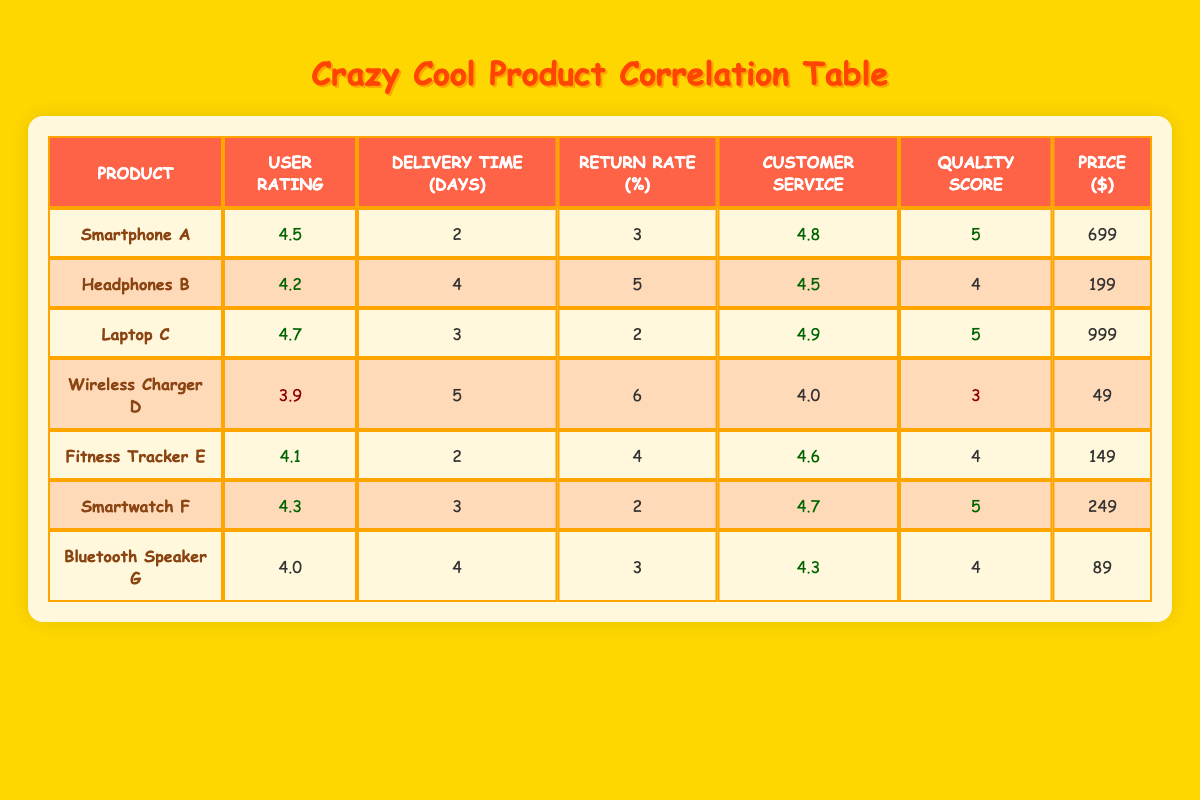What is the user rating of Laptop C? The user rating of Laptop C is listed in the corresponding row under "User Rating." Referring to the table, Laptop C has a user rating of 4.7.
Answer: 4.7 How many days did it take for the delivery of Wireless Charger D? The delivery time for Wireless Charger D is mentioned in the table. According to the row for Wireless Charger D, it took 5 days for the delivery.
Answer: 5 Which product has the highest customer service satisfaction? By checking the "Customer Service" column, we can identify the highest value. The highest customer service satisfaction is 4.9, which belongs to Laptop C.
Answer: Laptop C What is the average price of the products listed? To find the average price, we first sum the prices: 699 + 199 + 999 + 49 + 149 + 249 + 89 = 2433. There are 7 products, so the average price is 2433 divided by 7, which equals approximately 347.57.
Answer: 347.57 Is the return rate of Fitness Tracker E higher than the user rating of Smartphone A? The return rate of Fitness Tracker E is 4%, and the user rating of Smartphone A is 4.5. Since 4 is less than 4.5, the statement is false.
Answer: No Which product has the lowest quality score? The quality scores are compared, and the lowest score is found in Wireless Charger D, which has a score of 3.
Answer: Wireless Charger D Would you say that a lower price corresponds to a higher user rating based on the table data? To analyze, we look at the prices and user ratings together. Wireless Charger D has the lowest price (49) and a user rating of 3.9. In contrast, Laptop C is the highest priced (999) and has a high user rating of 4.7. This inconsistency suggests that a lower price does not consistently correlate with a higher user rating.
Answer: No How does the delivery time of Smartwatch F compare with the average delivery time? The delivery time for Smartwatch F is 3 days. To find the average, we total the delivery times (2 + 4 + 3 + 5 + 2 + 3 + 4 = 23) and divide by 7, resulting in an average delivery time of approximately 3.29 days. Smartwatch F's delivery time (3) is less than the average delivery time.
Answer: Less than average Which product has the highest user rating and the lowest return rate? To determine this, we look for the product with the highest user rating and then check its return rate. Laptop C has a user rating of 4.7 and a return rate of 2%, which is the lowest in the table. Therefore, Laptop C fulfills both conditions.
Answer: Laptop C 